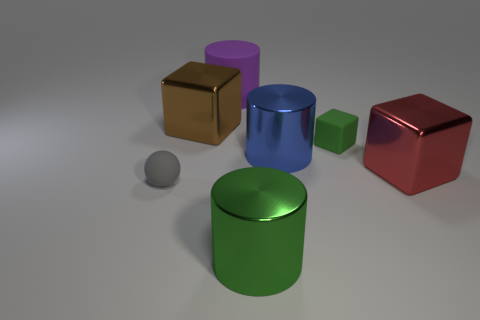Add 1 green rubber things. How many objects exist? 8 Subtract 0 purple blocks. How many objects are left? 7 Subtract all blocks. How many objects are left? 4 Subtract 2 cubes. How many cubes are left? 1 Subtract all brown cylinders. Subtract all red spheres. How many cylinders are left? 3 Subtract all blue blocks. How many blue cylinders are left? 1 Subtract all metal cubes. Subtract all green cylinders. How many objects are left? 4 Add 4 blue cylinders. How many blue cylinders are left? 5 Add 7 large green spheres. How many large green spheres exist? 7 Subtract all purple cylinders. How many cylinders are left? 2 